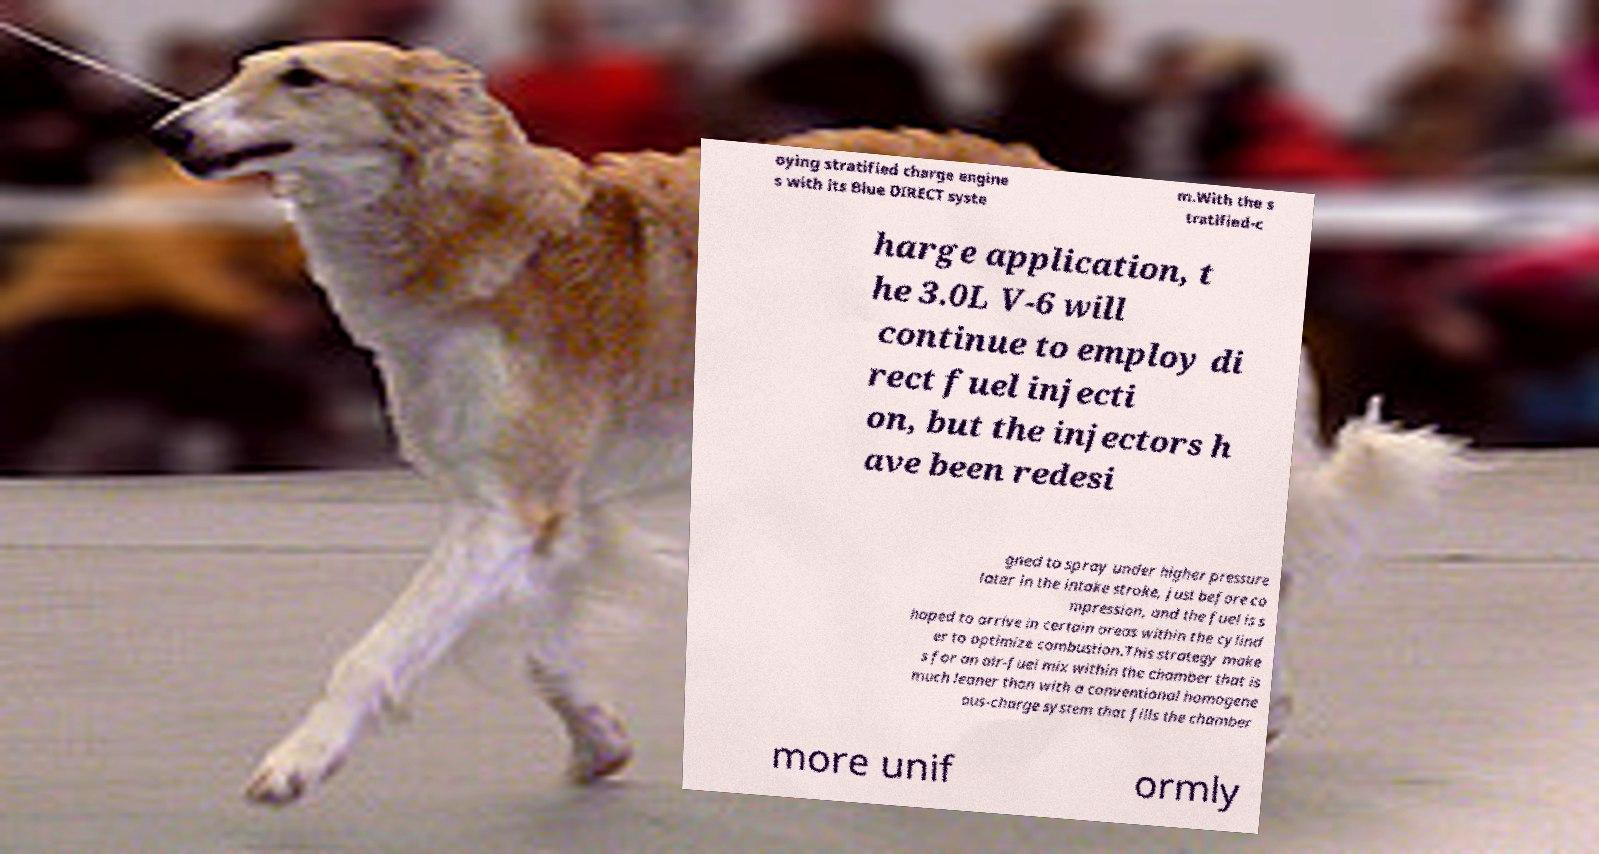Can you accurately transcribe the text from the provided image for me? oying stratified charge engine s with its Blue DIRECT syste m.With the s tratified-c harge application, t he 3.0L V-6 will continue to employ di rect fuel injecti on, but the injectors h ave been redesi gned to spray under higher pressure later in the intake stroke, just before co mpression, and the fuel is s haped to arrive in certain areas within the cylind er to optimize combustion.This strategy make s for an air-fuel mix within the chamber that is much leaner than with a conventional homogene ous-charge system that fills the chamber more unif ormly 